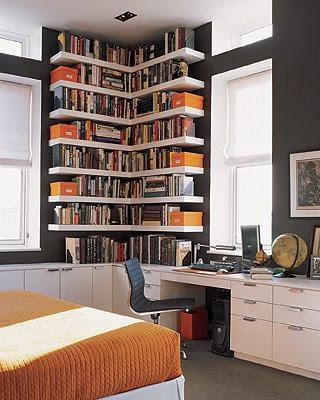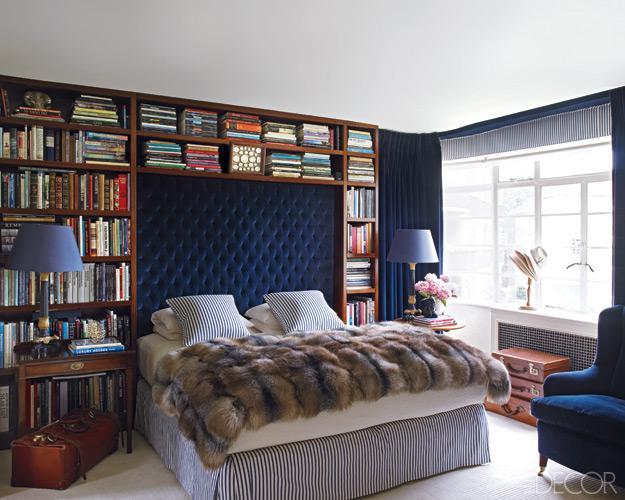The first image is the image on the left, the second image is the image on the right. Examine the images to the left and right. Is the description "An image shows a bed that extends from a recessed area created by bookshelves that surround it." accurate? Answer yes or no. Yes. The first image is the image on the left, the second image is the image on the right. Considering the images on both sides, is "The bookshelf in the image on the right frame an arch." valid? Answer yes or no. Yes. 